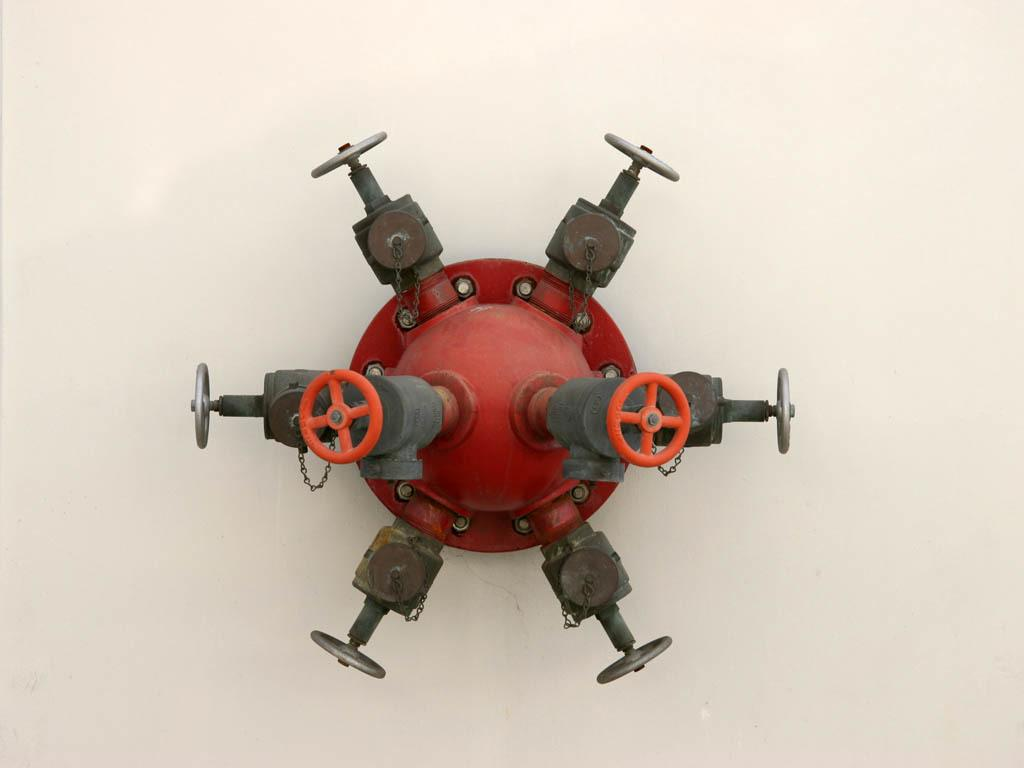What type of object is present in the image? There is a metal object in the image. What color is the metal object? The metal object is red in color. What can be seen in the background of the image? The background of the image is white. How does the metal object make a statement in the image? The metal object does not make a statement in the image; it is simply an object with a color. 